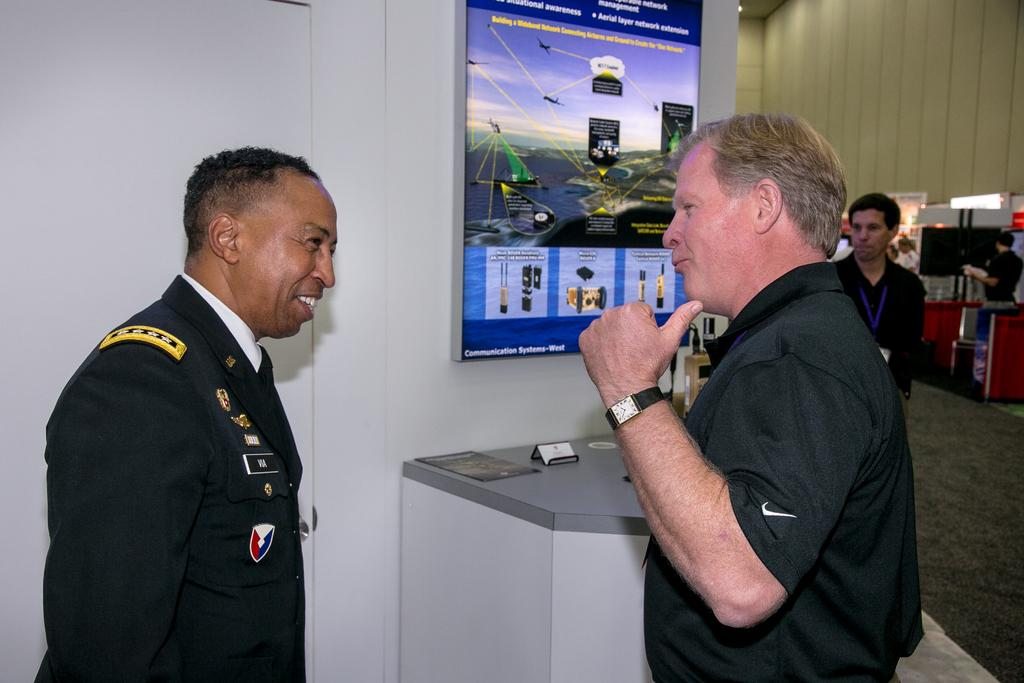How many people are in the image? There are two persons in the middle of the image, and additional persons on the right side of the image. What can be seen in the background of the image? There is a banner in the background of the image. What type of match is being played in the image? There is no match being played in the image; it does not depict any sporting event. 